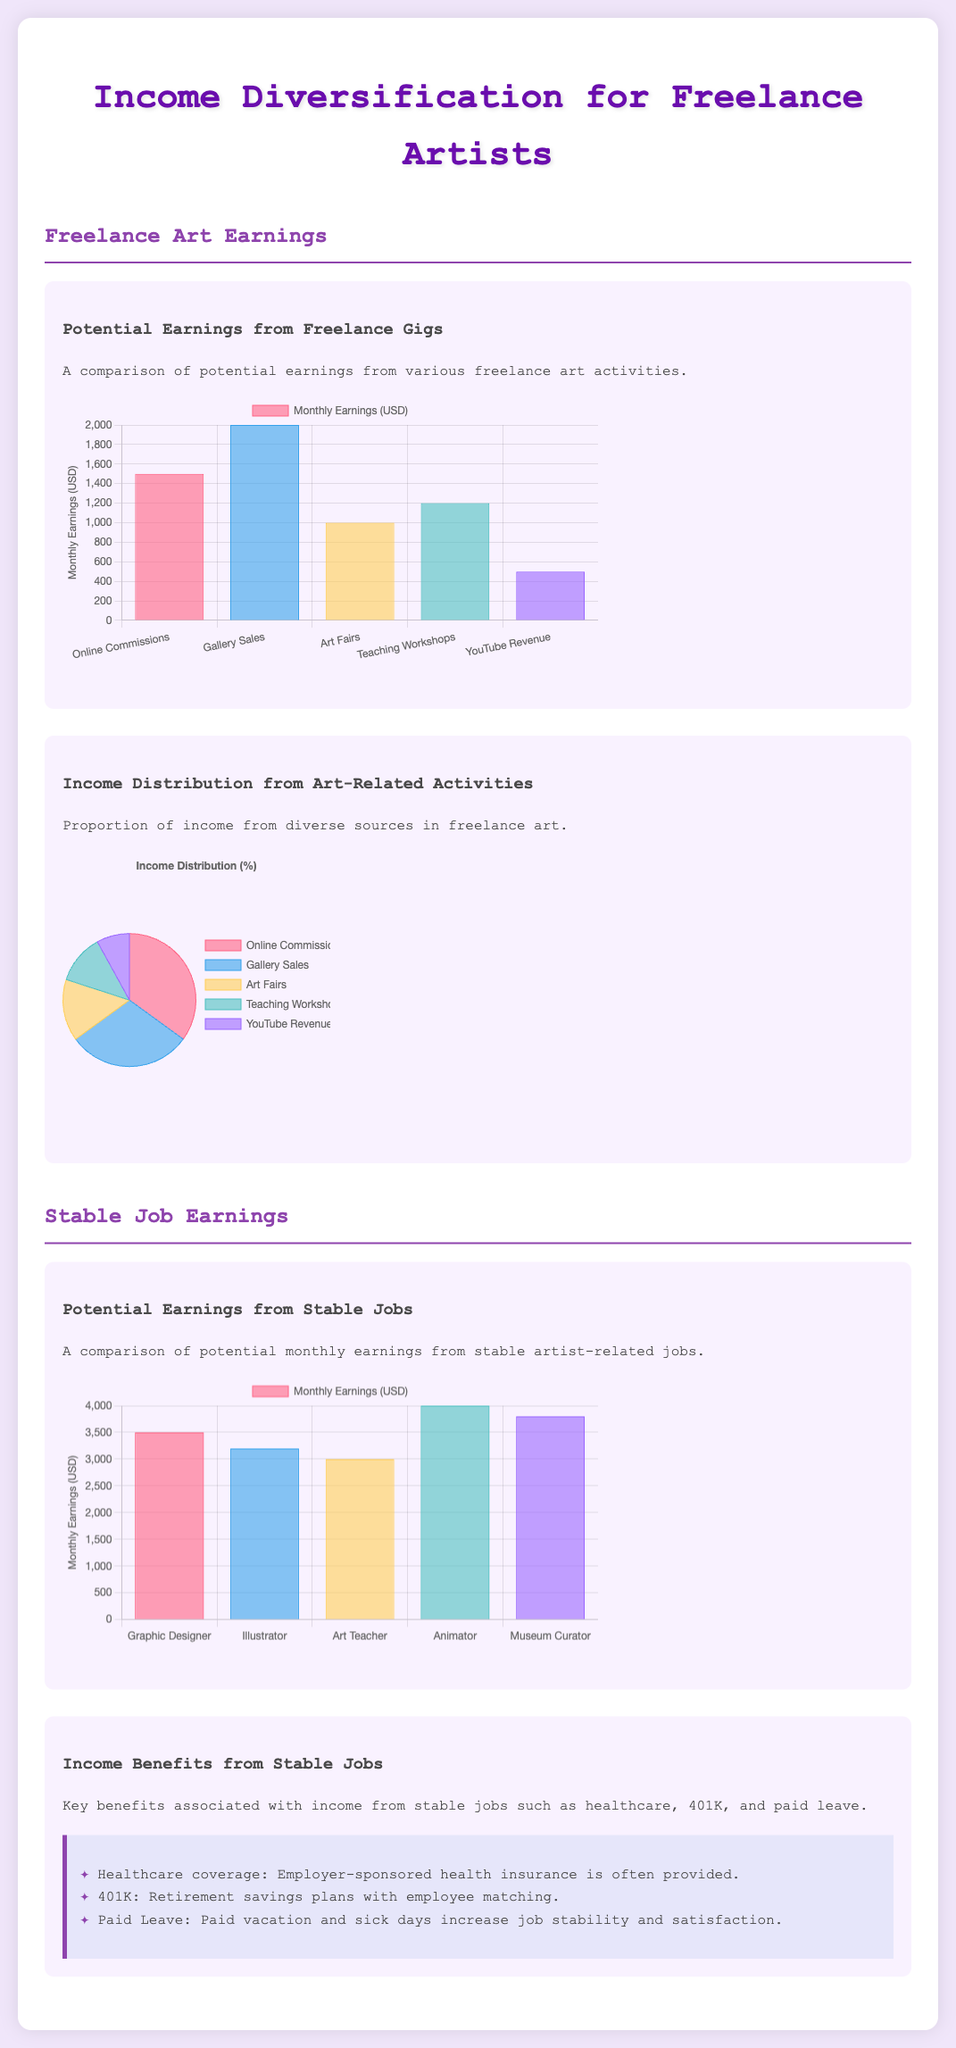What is the highest monthly earning from freelance gigs? The highest monthly earning from freelance gigs is shown in the bar graph as 2000 for Gallery Sales.
Answer: 2000 What percentage of income comes from Online Commissions? The pie chart indicates that Online Commissions account for 35% of the income distribution.
Answer: 35% Which stable job has the highest potential earnings? The bar graph for stable job earnings shows that the Animator has the highest potential earnings of 4000.
Answer: 4000 What is the total monthly earning for all freelance activities combined? The total can be calculated by summing the monthly earnings of all freelance activities, which gives 1500 + 2000 + 1000 + 1200 + 500 = 6200.
Answer: 6200 What are the key benefits of stable jobs mentioned? The document lists three benefits: Healthcare coverage, 401K, and Paid Leave.
Answer: Healthcare coverage, 401K, Paid Leave How much does an Illustrator earn monthly in stable jobs? The chart shows that an Illustrator earns 3200 monthly in stable jobs.
Answer: 3200 What is the percentage of income from Teaching Workshops? The pie chart indicates that Teaching Workshops represent 12% of total income.
Answer: 12% What is the potential earning for a Museum Curator? The bar graph for stable job earnings shows that a Museum Curator has potential earnings of 3800.
Answer: 3800 